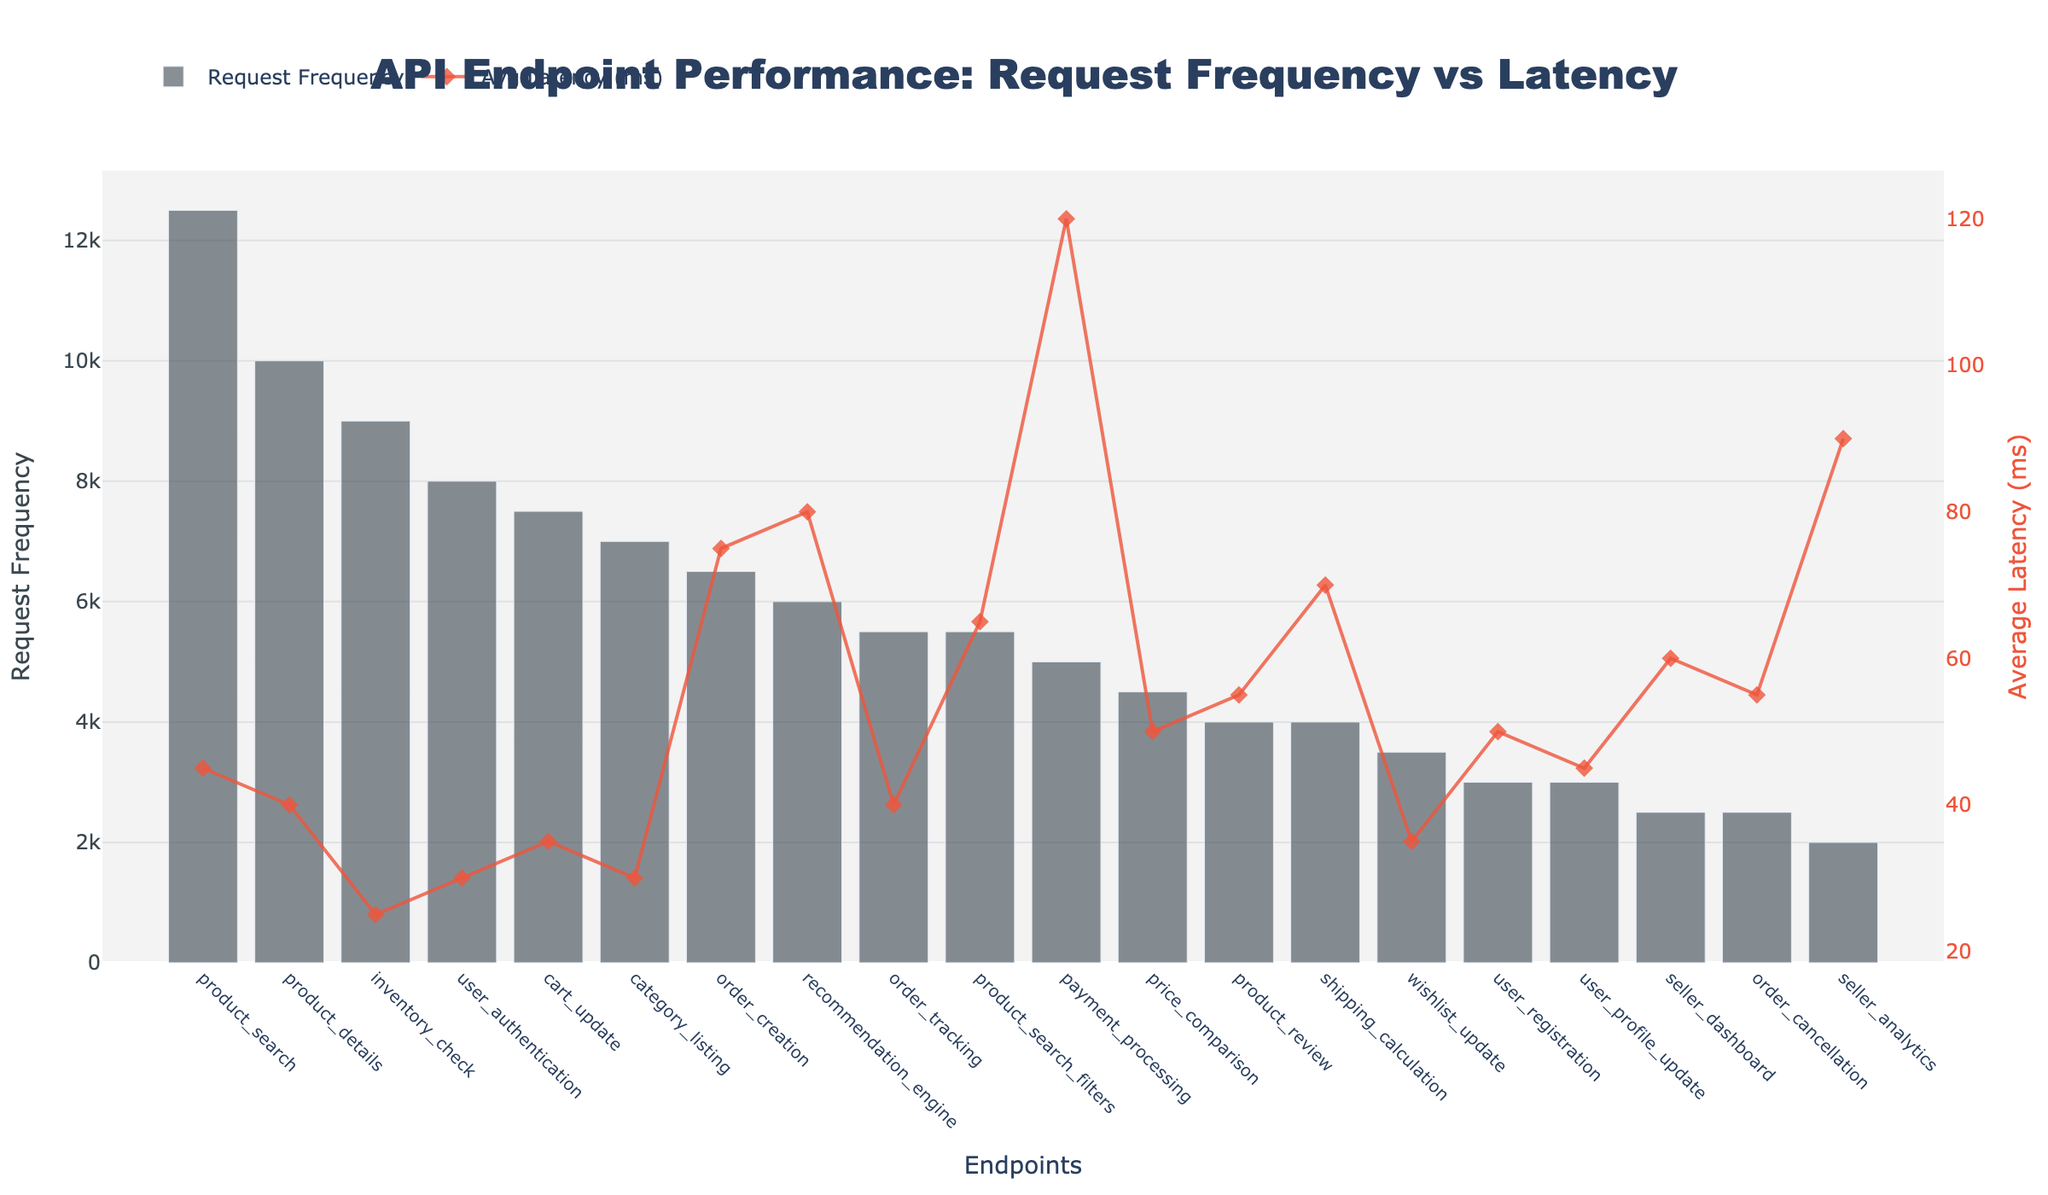what is the title of the figure? The title of the figure is located at the top and provides an overall description of the data being visualized. It is centered and uses a large font size.
Answer: API Endpoint Performance: Request Frequency vs Latency what are the labels of the y-axes? The y-axes have labels indicating what metric they represent. The left y-axis title is "Request Frequency," and the right y-axis title is "Average Latency (ms)."
Answer: Request Frequency, Average Latency (ms) which endpoint has the highest request frequency? To determine the endpoint with the highest request frequency, look for the bar that reaches the highest point on the left y-axis representing request frequency.
Answer: product_search which endpoint has the lowest average latency? To find the endpoint with the lowest average latency, look at the line plot on the right y-axis representing average latency. The lowest point on this line corresponds to the endpoint with the lowest average latency.
Answer: inventory_check compare the request frequency between 'order_creation' and 'payment_processing'. Visually inspect the height of the bars for 'order_creation' and 'payment_processing'. The 'order_creation' endpoint has a bar reaching 6500, while 'payment_processing' has a bar reaching 5000.
Answer: order_creation has higher request frequency which endpoint has the largest gap between request frequency and average latency? To find the largest gap, compare both metrics visually. One endpoint that stands out with a high request frequency and relatively high average latency is 'product_search'.
Answer: product_search what is the average latency for the 'payment_processing' endpoint? Locate the 'payment_processing' endpoint on the x-axis, then follow the corresponding marker on the line plot to the right y-axis to find the average latency.
Answer: 120 ms how many endpoints have an average latency above 60 ms? Count the number of markers on the line plot that are above the 60 ms mark on the right y-axis.
Answer: 5 rank the top three endpoints by request frequency. Look for the tallest bars on the bar plot, which represent the highest request frequencies. The endpoints corresponding to these bars are 'product_search', 'product_details', and 'inventory_check'.
Answer: product_search, product_details, inventory_check what is the median average latency among all endpoints? To find the median average latency, list the average latencies in ascending order and find the middle value (or average the two middle values if there's an even number of data points).
Answer: 45 ms 